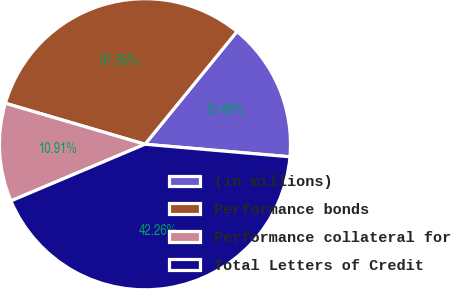Convert chart to OTSL. <chart><loc_0><loc_0><loc_500><loc_500><pie_chart><fcel>(in millions)<fcel>Performance bonds<fcel>Performance collateral for<fcel>Total Letters of Credit<nl><fcel>15.48%<fcel>31.35%<fcel>10.91%<fcel>42.26%<nl></chart> 